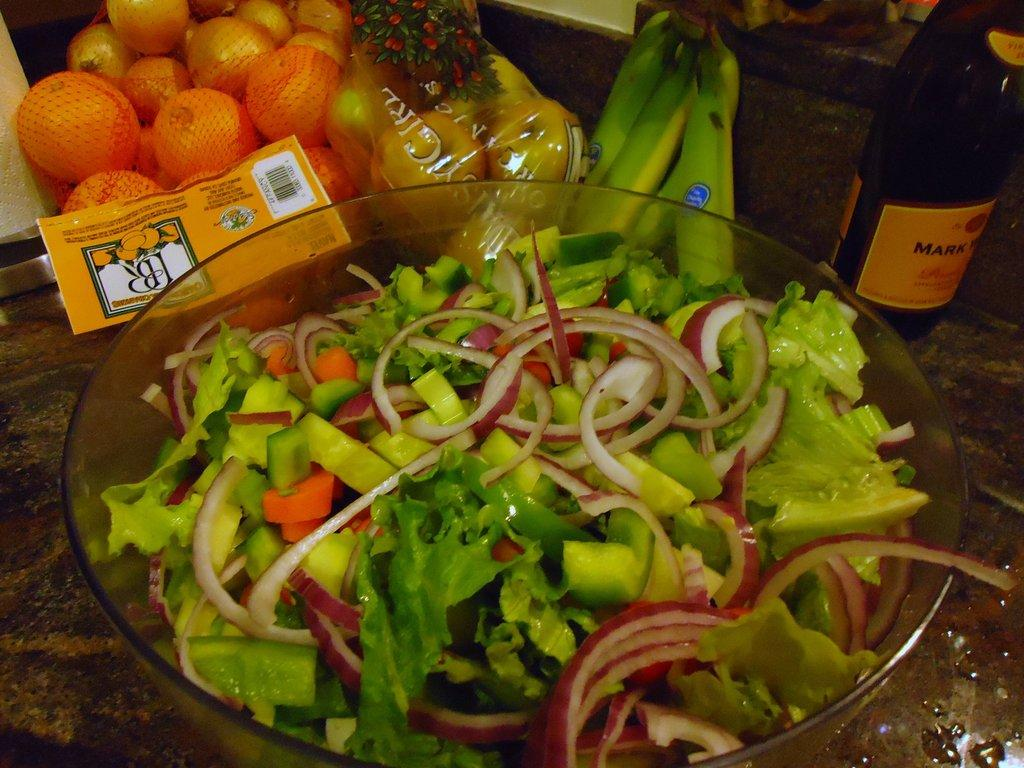What is in the bowl that is visible in the image? There is a bowl of salad in the image. What else can be seen in the image besides the salad? There is a bottle with text written on it in the image. What other types of food are present in the image? There are fruits in the image. Can you see any wings on the fruits in the image? There are no wings present on the fruits in the image. What type of pen is used to write on the bottle in the image? There is no pen visible in the image, as the text on the bottle is already written. 